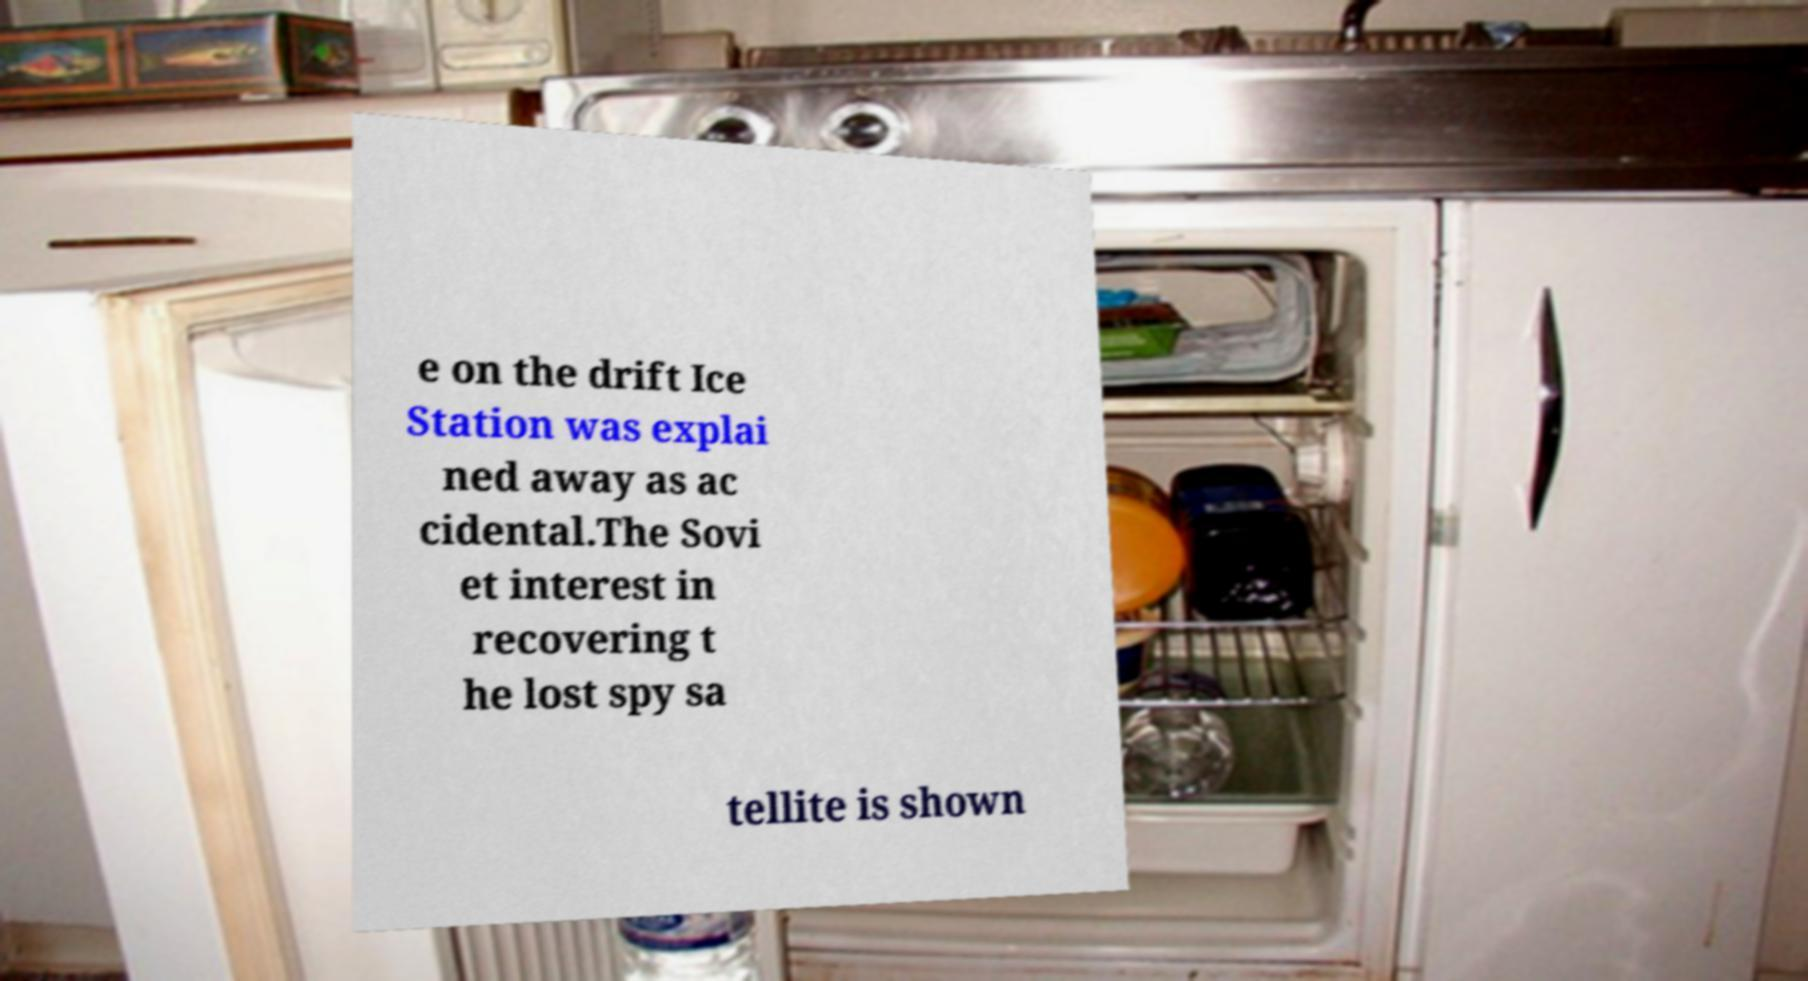Could you extract and type out the text from this image? e on the drift Ice Station was explai ned away as ac cidental.The Sovi et interest in recovering t he lost spy sa tellite is shown 